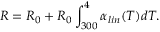<formula> <loc_0><loc_0><loc_500><loc_500>R = R _ { 0 } + R _ { 0 } \int _ { 3 0 0 } ^ { 4 } \alpha _ { l i n } ( T ) d T .</formula> 